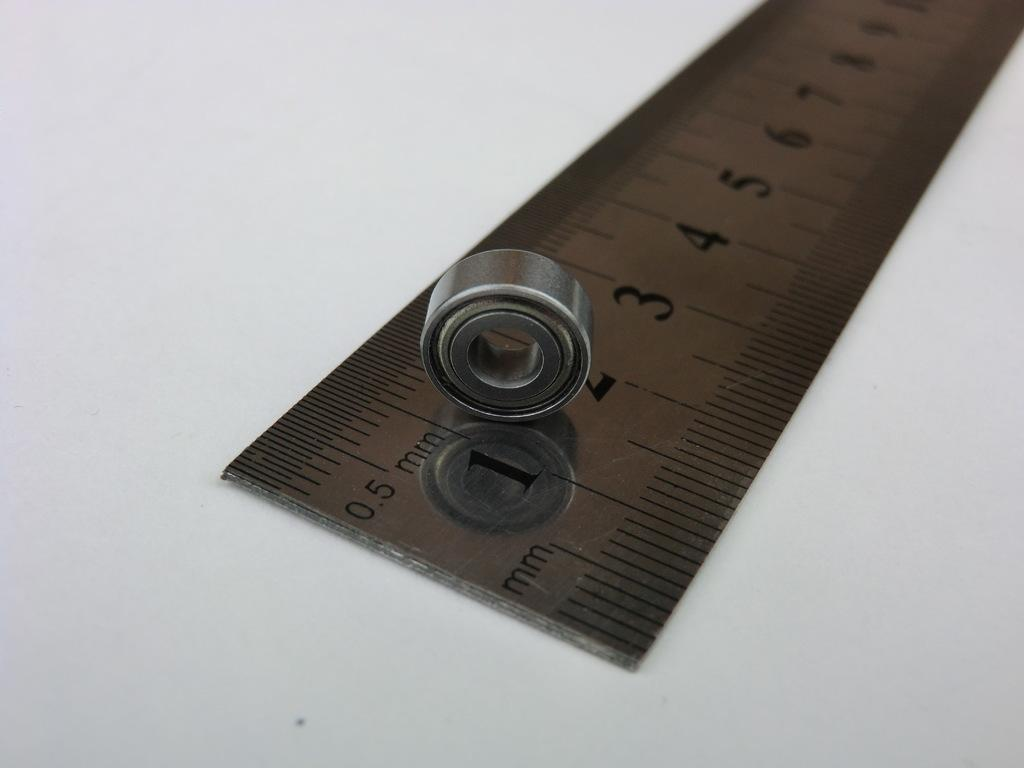Provide a one-sentence caption for the provided image. A silver ruler that measure in mm with a nut on it. 